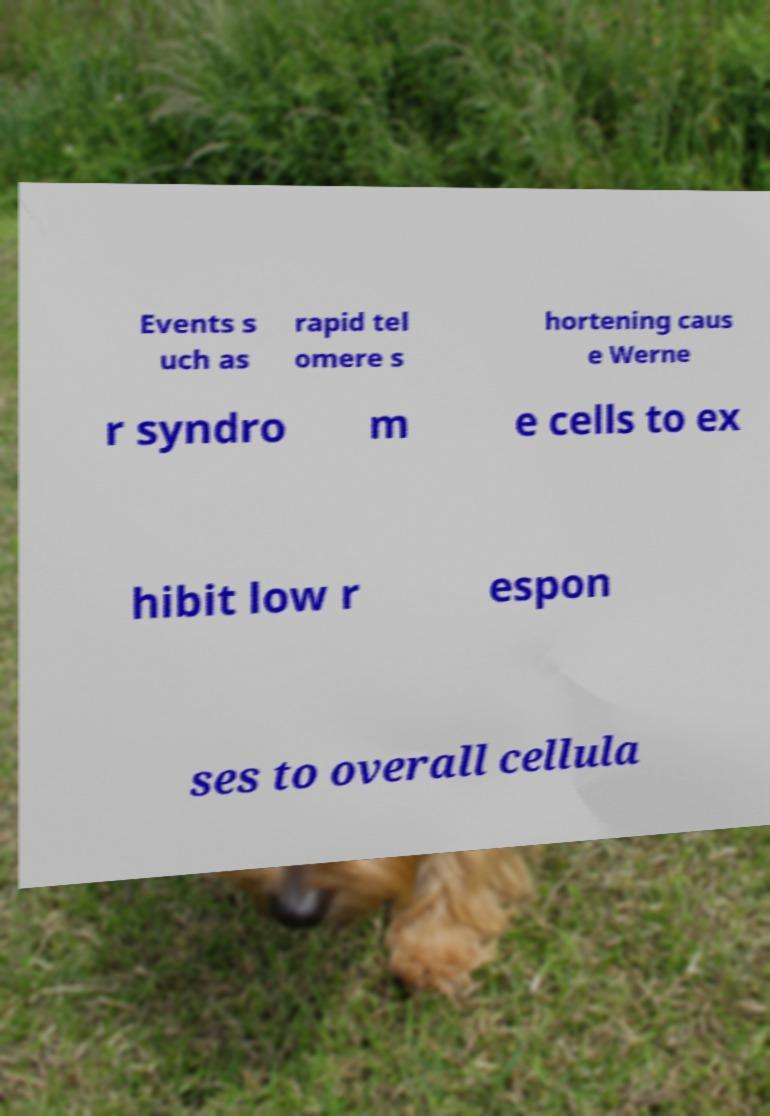Can you accurately transcribe the text from the provided image for me? Events s uch as rapid tel omere s hortening caus e Werne r syndro m e cells to ex hibit low r espon ses to overall cellula 